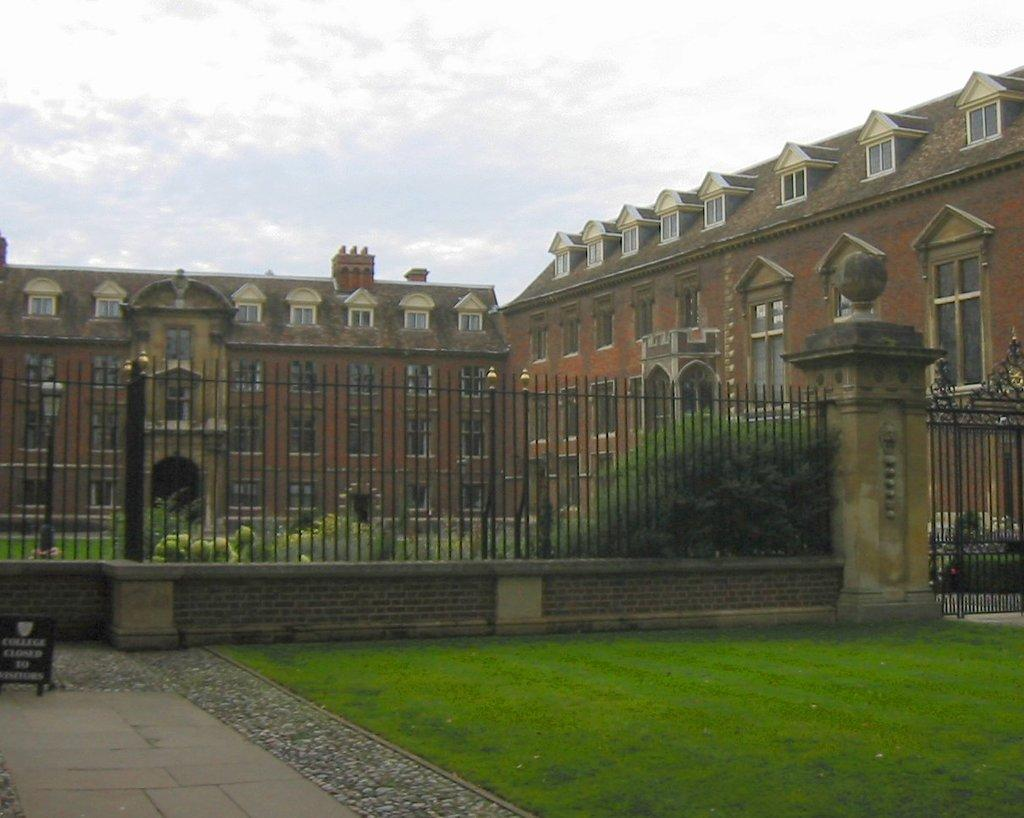What type of surface is present on the ground in the image? There is grass on the ground in the image. What object can be seen on the grass in the image? There is a board on the surface in the image. What structures are present in the image? There is a wall, a fence, and a gate in the image. What can be seen in the background of the image? In the background, there are plants, a building, windows, and clouds visible. What type of sheet is draped over the gate in the image? There is no sheet present in the image; the gate is visible without any draping. 